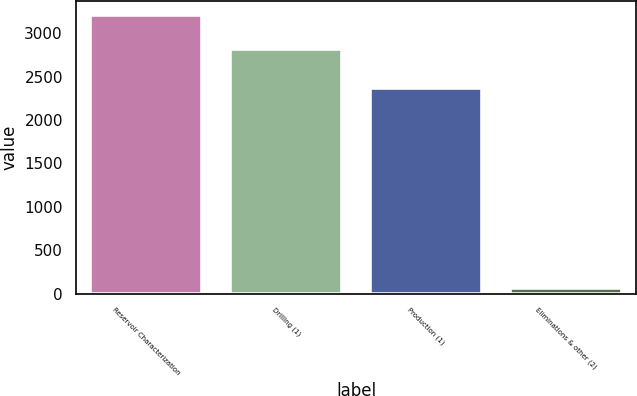Convert chart to OTSL. <chart><loc_0><loc_0><loc_500><loc_500><bar_chart><fcel>Reservoir Characterization<fcel>Drilling (1)<fcel>Production (1)<fcel>Eliminations & other (2)<nl><fcel>3212<fcel>2824<fcel>2371<fcel>60<nl></chart> 